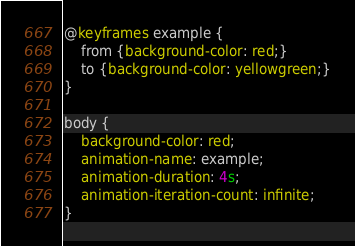<code> <loc_0><loc_0><loc_500><loc_500><_CSS_>@keyframes example {
    from {background-color: red;}
    to {background-color: yellowgreen;}
}

body {
    background-color: red;
    animation-name: example;
    animation-duration: 4s;
    animation-iteration-count: infinite;
}
</code> 